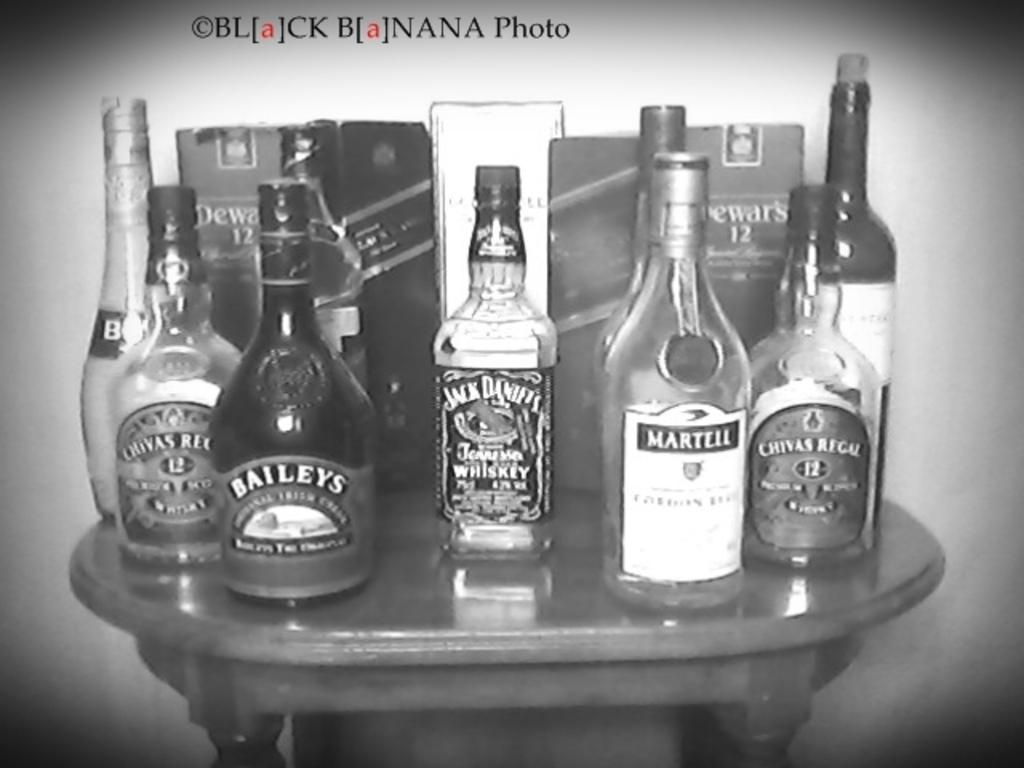<image>
Describe the image concisely. A collections of alcoholic beverages including Jack Daniels and Baileys. 